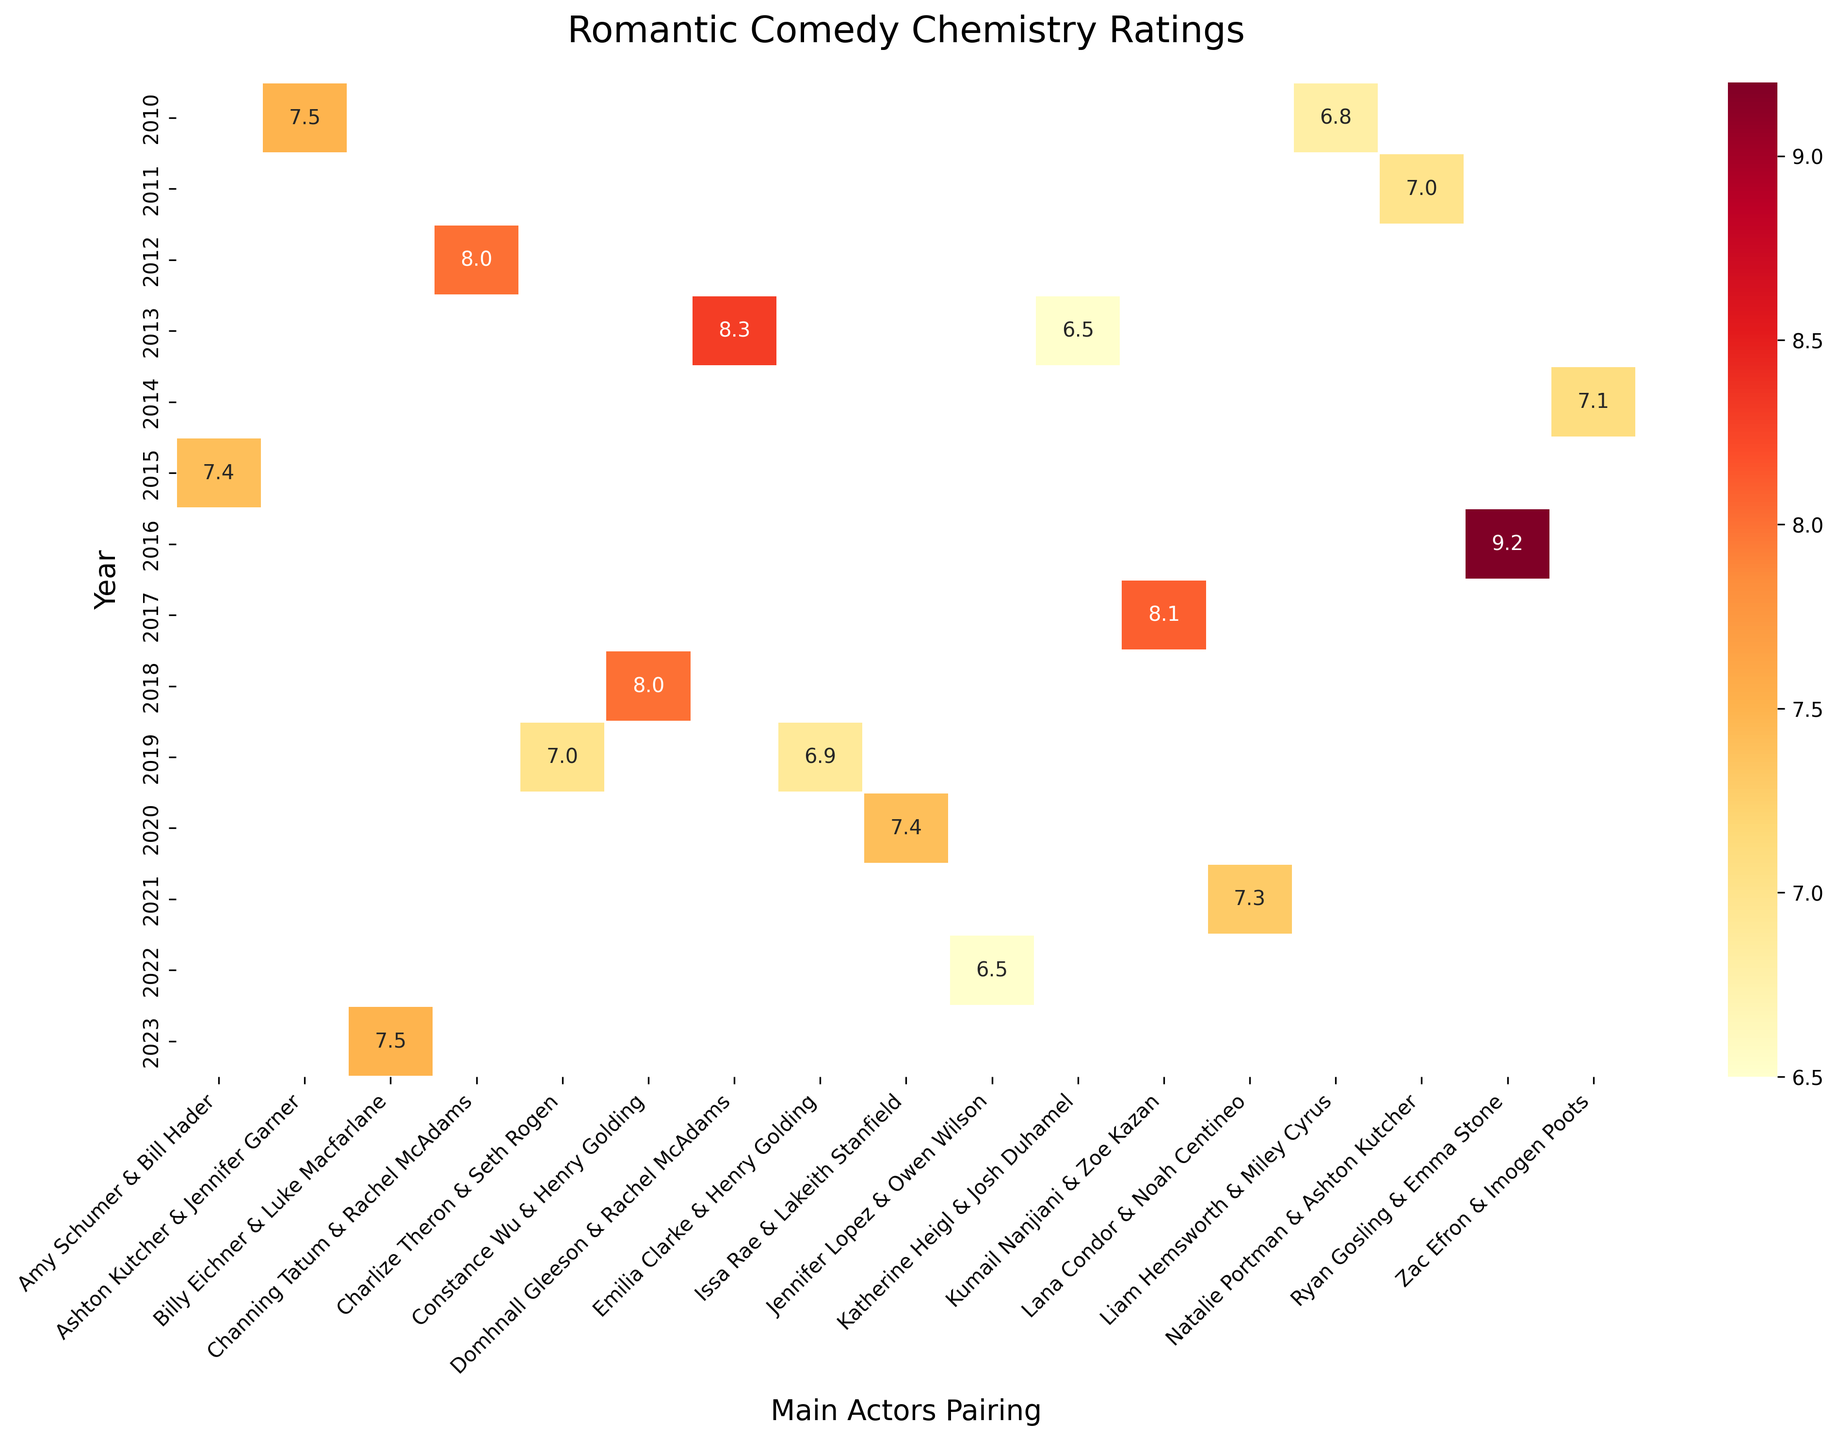What does the heatmap title say? The title of the heatmap is typically placed at the top of the figure. It provides an overview of what the figure represents, which is the distribution of chemistry ratings among romantic comedy main actor pairings for various years.
Answer: Romantic Comedy Chemistry Ratings Which year has the highest chemistry rating and what is the rating? To find the highest chemistry rating, scan through the heatmap to identify the highest value among all the cells.
Answer: 2016, 9.2 How many romantic comedy movies are listed from the year 2013? Look down the column representing the year 2013 and count the number of cells containing data points.
Answer: 2 What is the chemistry rating for "Crazy Rich Asians" released in 2018? Identify the row corresponding to the year 2018 and find the specific chemistry rating in the cell that mentions "Crazy Rich Asians".
Answer: 8.0 Which main actors pairing appears in the heatmap and has the closest chemistry rating to 7.0 in the year 2011? Look at the year row 2011 and scan the ratings. Identify the value closest to 7.0 and note the corresponding main actor pairing.
Answer: Natalie Portman & Ashton Kutcher Between 2010 and 2023, which year contains the highest number of movies listed in the heatmap? Count the number of data points in each row corresponding to each year from 2010 to 2023, and identify the row with the highest count.
Answer: 2019 What is the average chemistry rating for the movies listed in 2013? Identify the chemistry ratings for the two movies listed in 2013. Calculate the sum of these ratings and divide by the number of movies. The ratings are 8.3 and 6.5. Sum them to get 14.8 and divide by 2 to get the average.
Answer: 7.4 Compare the chemistry rating between "The Big Sick" (2017) and "Long Shot" (2019). Which one is higher? Identify the cells corresponding to "The Big Sick" in 2017 and "Long Shot" in 2019. Compare their chemistry ratings.
Answer: The Big Sick How does the chemistry rating of "Bros" in 2023 compare to "Valentine's Day" in 2010? Look at the chemistry ratings for "Bros" in 2023 and "Valentine's Day" in 2010 and compare these two values.
Answer: Same Which main actor pairing has received the lowest chemistry rating and what is that rating? Scan all cells to find the lowest chemistry rating and note the main actor pairing associated with that cell.
Answer: Katherine Heigl & Josh Duhamel, 6.5 